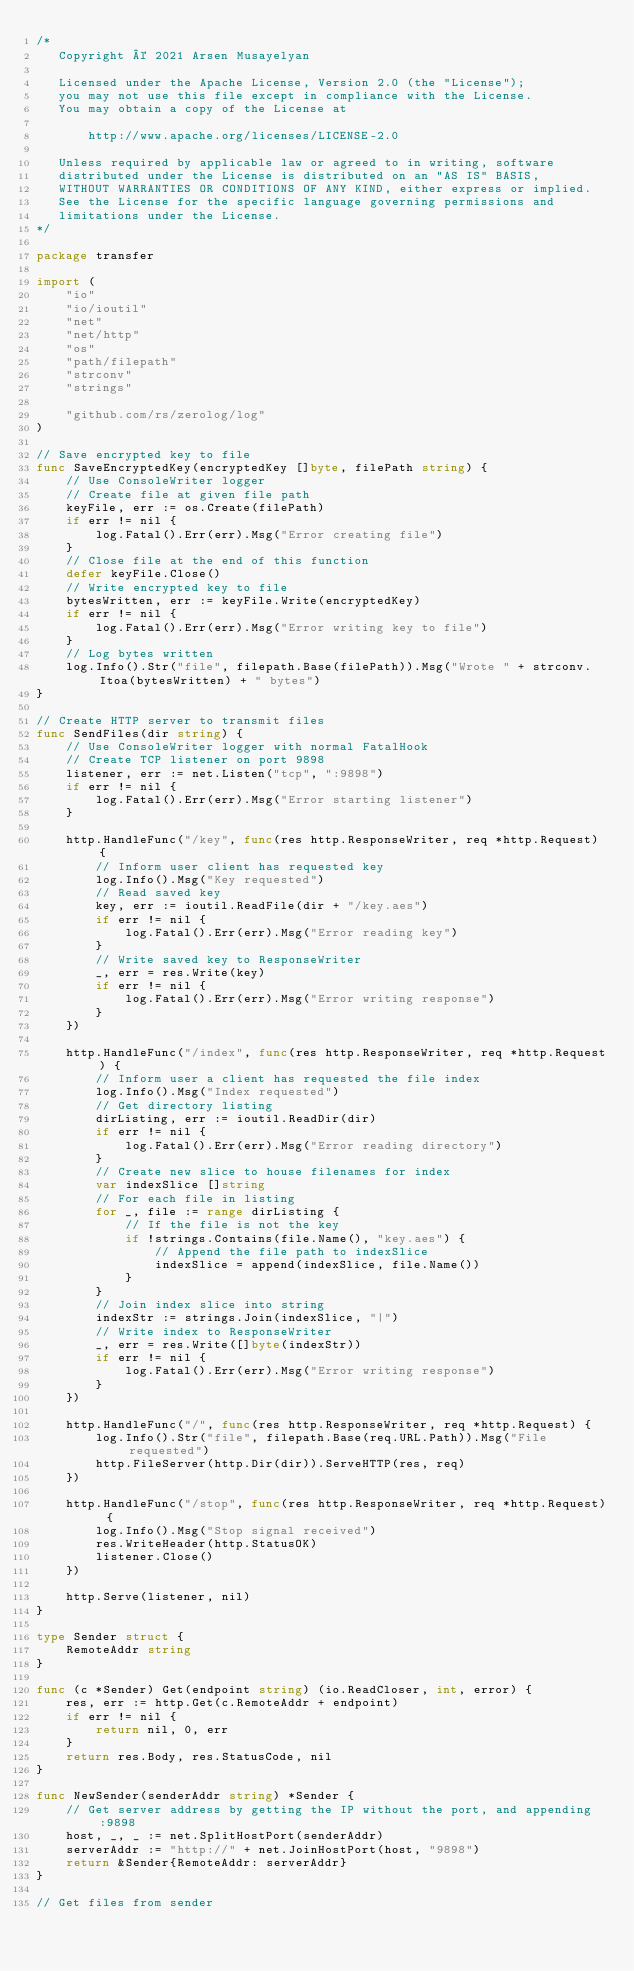<code> <loc_0><loc_0><loc_500><loc_500><_Go_>/*
   Copyright © 2021 Arsen Musayelyan

   Licensed under the Apache License, Version 2.0 (the "License");
   you may not use this file except in compliance with the License.
   You may obtain a copy of the License at

       http://www.apache.org/licenses/LICENSE-2.0

   Unless required by applicable law or agreed to in writing, software
   distributed under the License is distributed on an "AS IS" BASIS,
   WITHOUT WARRANTIES OR CONDITIONS OF ANY KIND, either express or implied.
   See the License for the specific language governing permissions and
   limitations under the License.
*/

package transfer

import (
	"io"
	"io/ioutil"
	"net"
	"net/http"
	"os"
	"path/filepath"
	"strconv"
	"strings"

	"github.com/rs/zerolog/log"
)

// Save encrypted key to file
func SaveEncryptedKey(encryptedKey []byte, filePath string) {
	// Use ConsoleWriter logger
	// Create file at given file path
	keyFile, err := os.Create(filePath)
	if err != nil {
		log.Fatal().Err(err).Msg("Error creating file")
	}
	// Close file at the end of this function
	defer keyFile.Close()
	// Write encrypted key to file
	bytesWritten, err := keyFile.Write(encryptedKey)
	if err != nil {
		log.Fatal().Err(err).Msg("Error writing key to file")
	}
	// Log bytes written
	log.Info().Str("file", filepath.Base(filePath)).Msg("Wrote " + strconv.Itoa(bytesWritten) + " bytes")
}

// Create HTTP server to transmit files
func SendFiles(dir string) {
	// Use ConsoleWriter logger with normal FatalHook
	// Create TCP listener on port 9898
	listener, err := net.Listen("tcp", ":9898")
	if err != nil {
		log.Fatal().Err(err).Msg("Error starting listener")
	}

	http.HandleFunc("/key", func(res http.ResponseWriter, req *http.Request) {
		// Inform user client has requested key
		log.Info().Msg("Key requested")
		// Read saved key
		key, err := ioutil.ReadFile(dir + "/key.aes")
		if err != nil {
			log.Fatal().Err(err).Msg("Error reading key")
		}
		// Write saved key to ResponseWriter
		_, err = res.Write(key)
		if err != nil {
			log.Fatal().Err(err).Msg("Error writing response")
		}
	})

	http.HandleFunc("/index", func(res http.ResponseWriter, req *http.Request) {
		// Inform user a client has requested the file index
		log.Info().Msg("Index requested")
		// Get directory listing
		dirListing, err := ioutil.ReadDir(dir)
		if err != nil {
			log.Fatal().Err(err).Msg("Error reading directory")
		}
		// Create new slice to house filenames for index
		var indexSlice []string
		// For each file in listing
		for _, file := range dirListing {
			// If the file is not the key
			if !strings.Contains(file.Name(), "key.aes") {
				// Append the file path to indexSlice
				indexSlice = append(indexSlice, file.Name())
			}
		}
		// Join index slice into string
		indexStr := strings.Join(indexSlice, "|")
		// Write index to ResponseWriter
		_, err = res.Write([]byte(indexStr))
		if err != nil {
			log.Fatal().Err(err).Msg("Error writing response")
		}
	})

	http.HandleFunc("/", func(res http.ResponseWriter, req *http.Request) {
		log.Info().Str("file", filepath.Base(req.URL.Path)).Msg("File requested")
		http.FileServer(http.Dir(dir)).ServeHTTP(res, req)
	})

	http.HandleFunc("/stop", func(res http.ResponseWriter, req *http.Request) {
		log.Info().Msg("Stop signal received")
		res.WriteHeader(http.StatusOK)
		listener.Close()
	})

	http.Serve(listener, nil)
}

type Sender struct {
	RemoteAddr string
}

func (c *Sender) Get(endpoint string) (io.ReadCloser, int, error) {
	res, err := http.Get(c.RemoteAddr + endpoint)
	if err != nil {
		return nil, 0, err
	}
	return res.Body, res.StatusCode, nil
}

func NewSender(senderAddr string) *Sender {
	// Get server address by getting the IP without the port, and appending :9898
	host, _, _ := net.SplitHostPort(senderAddr)
	serverAddr := "http://" + net.JoinHostPort(host, "9898")
	return &Sender{RemoteAddr: serverAddr}
}

// Get files from sender</code> 